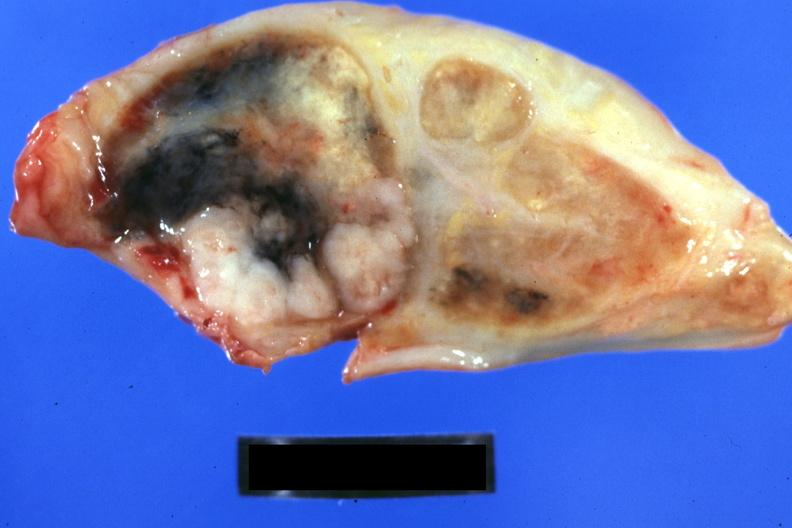does this image show obvious tumor with necrosis and anthracotic pigment 44yo bf adenocarcinoma of lung giant cell type?
Answer the question using a single word or phrase. Yes 